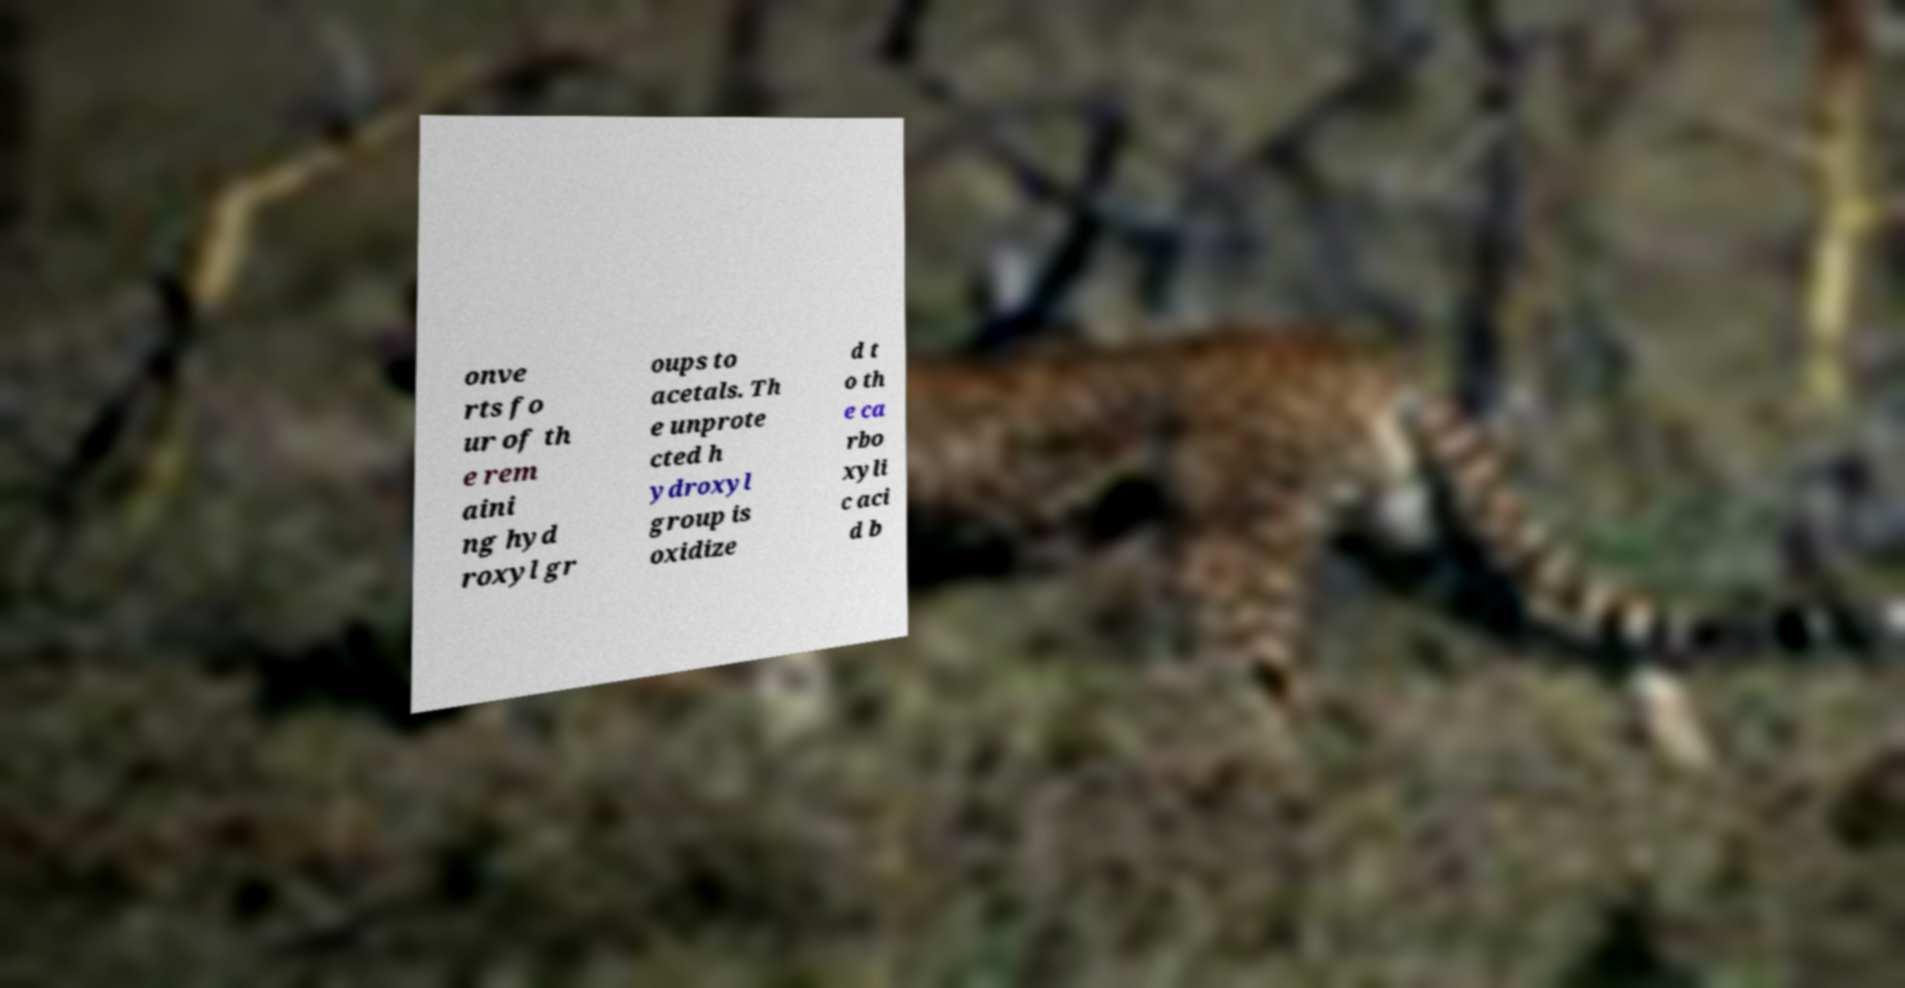For documentation purposes, I need the text within this image transcribed. Could you provide that? onve rts fo ur of th e rem aini ng hyd roxyl gr oups to acetals. Th e unprote cted h ydroxyl group is oxidize d t o th e ca rbo xyli c aci d b 